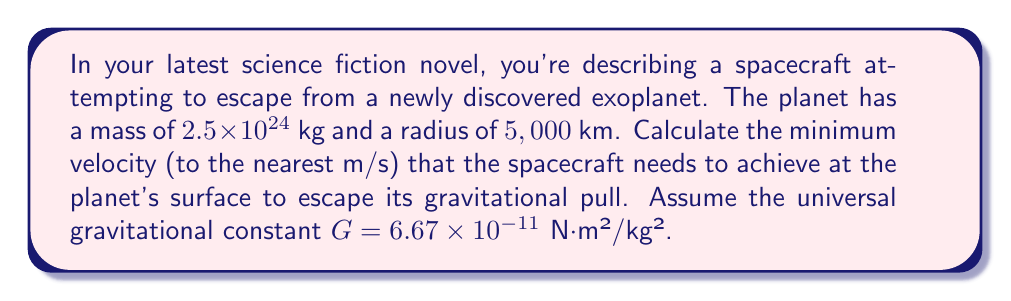Help me with this question. To solve this problem, we need to use the escape velocity formula:

$$v_e = \sqrt{\frac{2GM}{R}}$$

Where:
$v_e$ is the escape velocity
$G$ is the universal gravitational constant
$M$ is the mass of the planet
$R$ is the radius of the planet

Let's plug in the values:

$G = 6.67 \times 10^{-11}$ N⋅m²/kg²
$M = 2.5 \times 10^{24}$ kg
$R = 5,000,000$ m (converting km to m)

Now, let's calculate:

$$\begin{align}
v_e &= \sqrt{\frac{2 \times (6.67 \times 10^{-11}) \times (2.5 \times 10^{24})}{5,000,000}} \\[2ex]
&= \sqrt{\frac{3.335 \times 10^{14}}{5 \times 10^6}} \\[2ex]
&= \sqrt{6.67 \times 10^7} \\[2ex]
&= 8,167.93 \text{ m/s}
\end{align}$$

Rounding to the nearest m/s, we get 8,168 m/s.
Answer: 8,168 m/s 